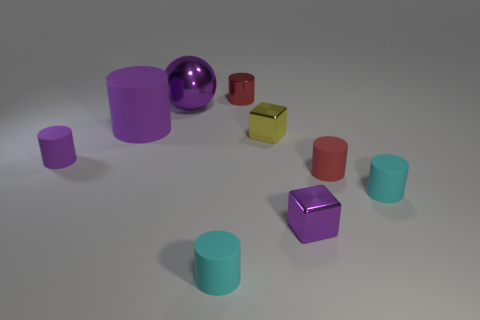What can you infer about the texture of the objects? Based on the lighting and shadows, the objects appear to have different textures. The purple sphere, for instance, has a glossy, reflective surface, suggesting it might be made of a smooth, rubber-like material. In contrast, the matte finish on the green cylinders and cube indicates a less reflective, likely rougher texture, possibly resembling plastic or coated wood. 